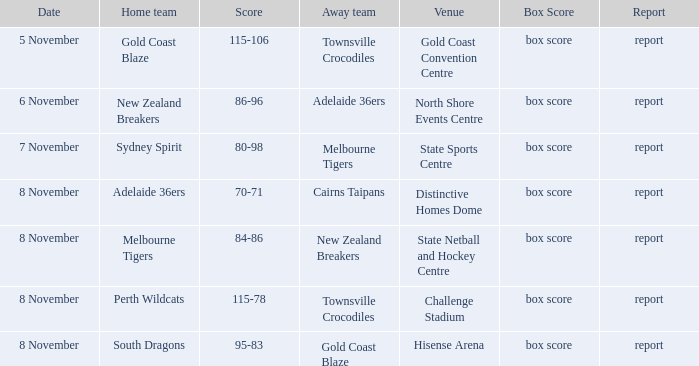What was the date that featured a game against Gold Coast Blaze? 8 November. Help me parse the entirety of this table. {'header': ['Date', 'Home team', 'Score', 'Away team', 'Venue', 'Box Score', 'Report'], 'rows': [['5 November', 'Gold Coast Blaze', '115-106', 'Townsville Crocodiles', 'Gold Coast Convention Centre', 'box score', 'report'], ['6 November', 'New Zealand Breakers', '86-96', 'Adelaide 36ers', 'North Shore Events Centre', 'box score', 'report'], ['7 November', 'Sydney Spirit', '80-98', 'Melbourne Tigers', 'State Sports Centre', 'box score', 'report'], ['8 November', 'Adelaide 36ers', '70-71', 'Cairns Taipans', 'Distinctive Homes Dome', 'box score', 'report'], ['8 November', 'Melbourne Tigers', '84-86', 'New Zealand Breakers', 'State Netball and Hockey Centre', 'box score', 'report'], ['8 November', 'Perth Wildcats', '115-78', 'Townsville Crocodiles', 'Challenge Stadium', 'box score', 'report'], ['8 November', 'South Dragons', '95-83', 'Gold Coast Blaze', 'Hisense Arena', 'box score', 'report']]} 